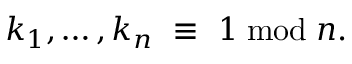<formula> <loc_0><loc_0><loc_500><loc_500>k _ { 1 } , \dots , k _ { n } \ \equiv \ 1 \bmod n .</formula> 